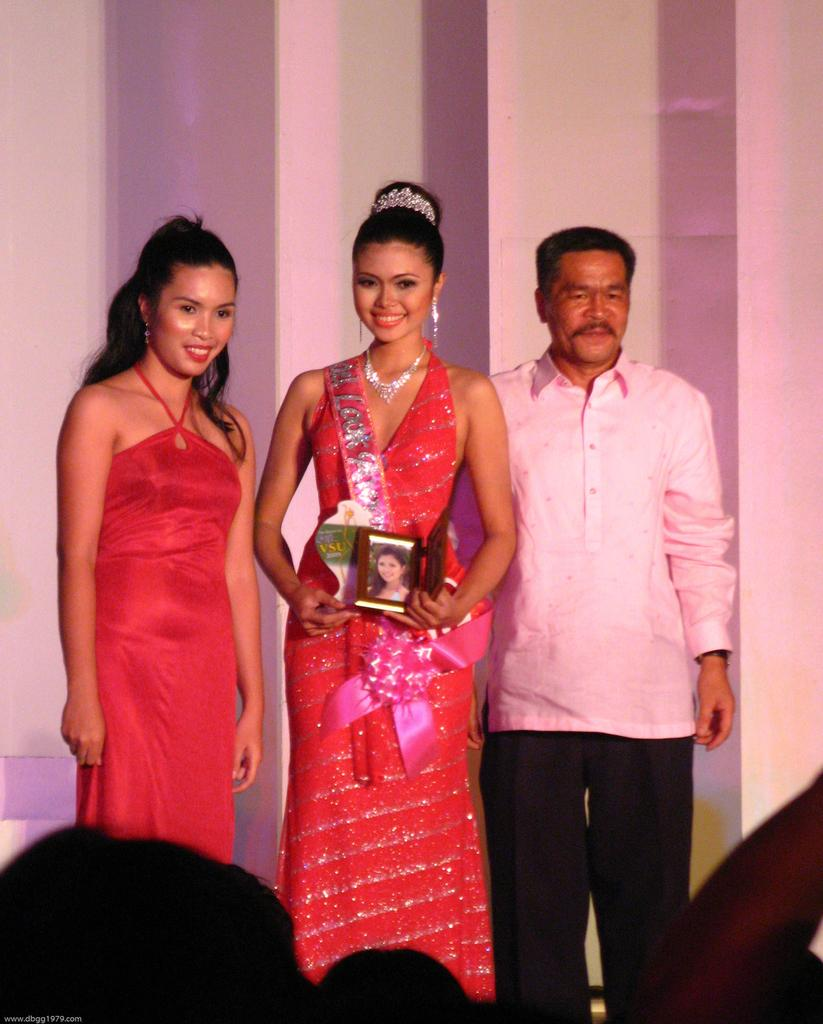How many people are in the image? There are people in the image, but the exact number is not specified. What is one of the people holding? One of the people is holding a photo frame. What can be seen in the background of the image? There is a wall visible in the background of the image. What type of key is being used to unlock the system in the image? There is no key or system present in the image; it only features people and a photo frame. 